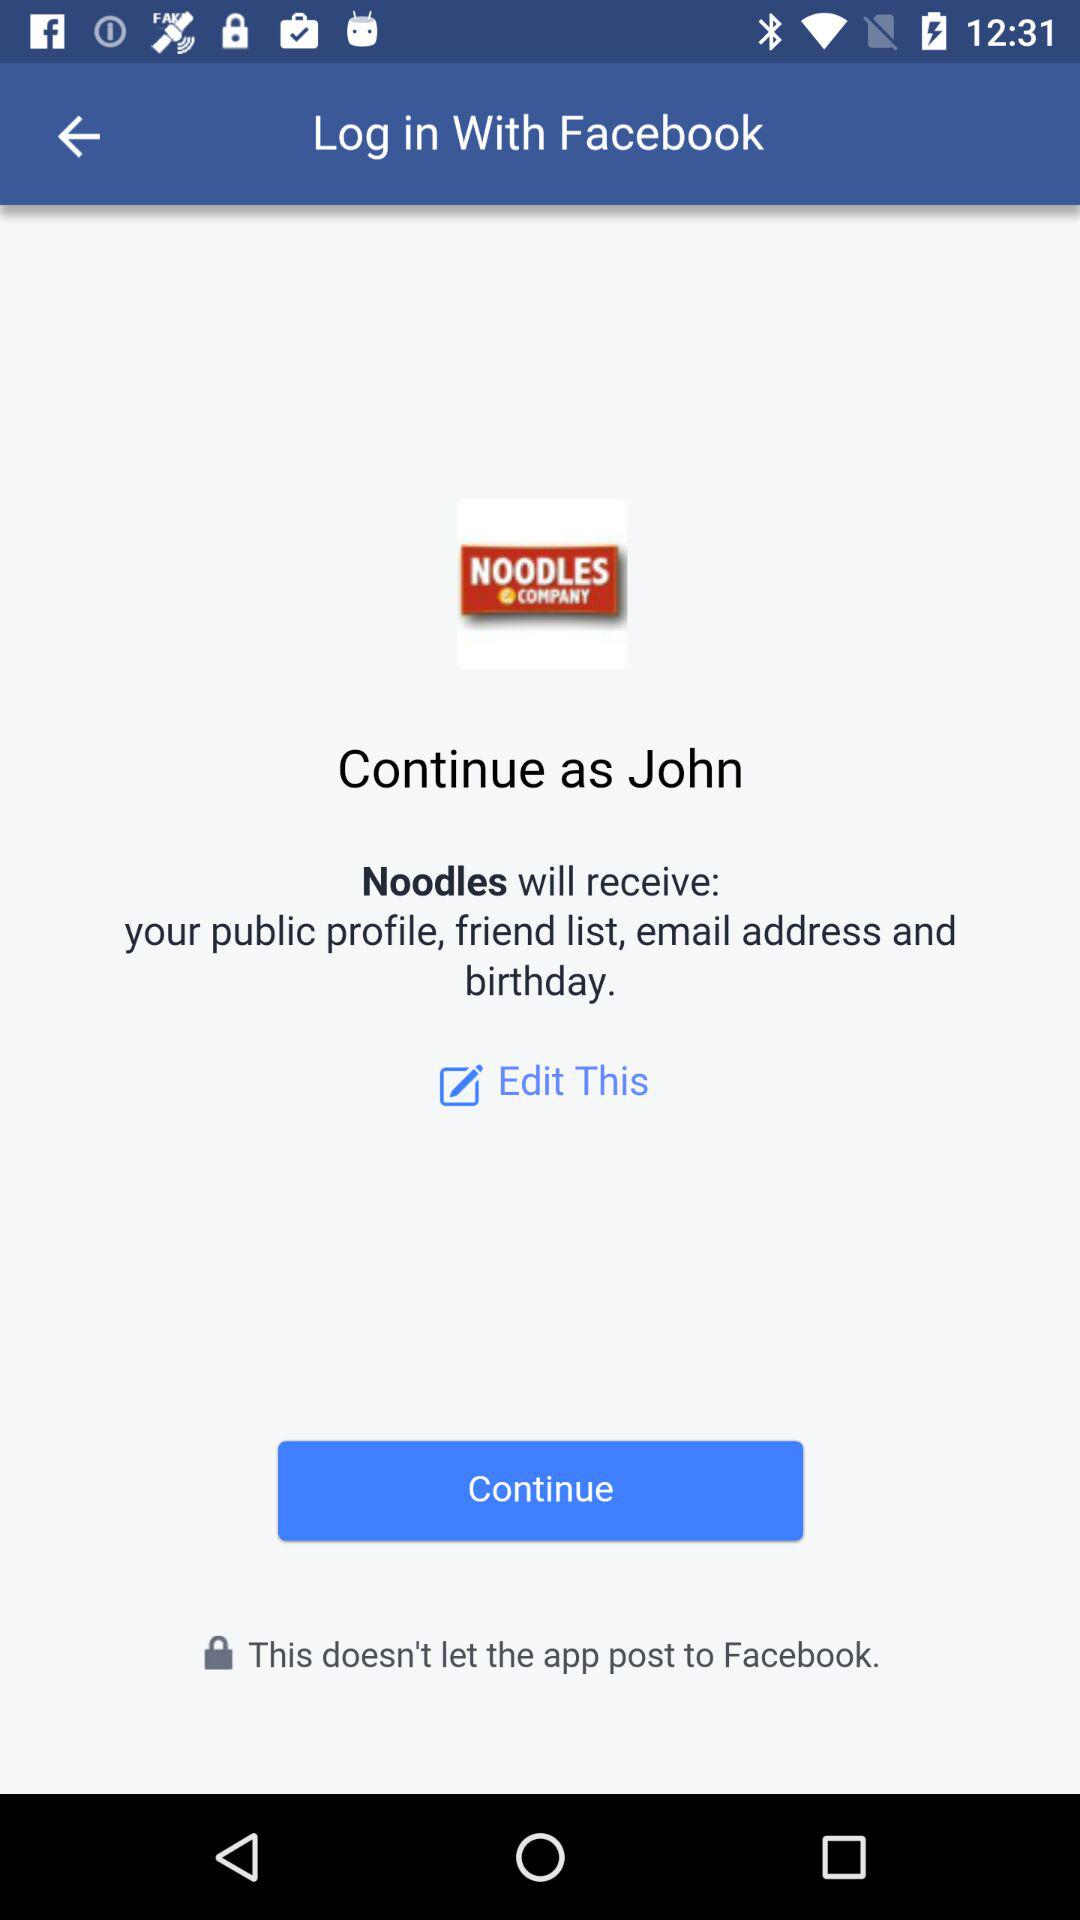What application is asking for permission? The application asking for permission is "Noodles". 